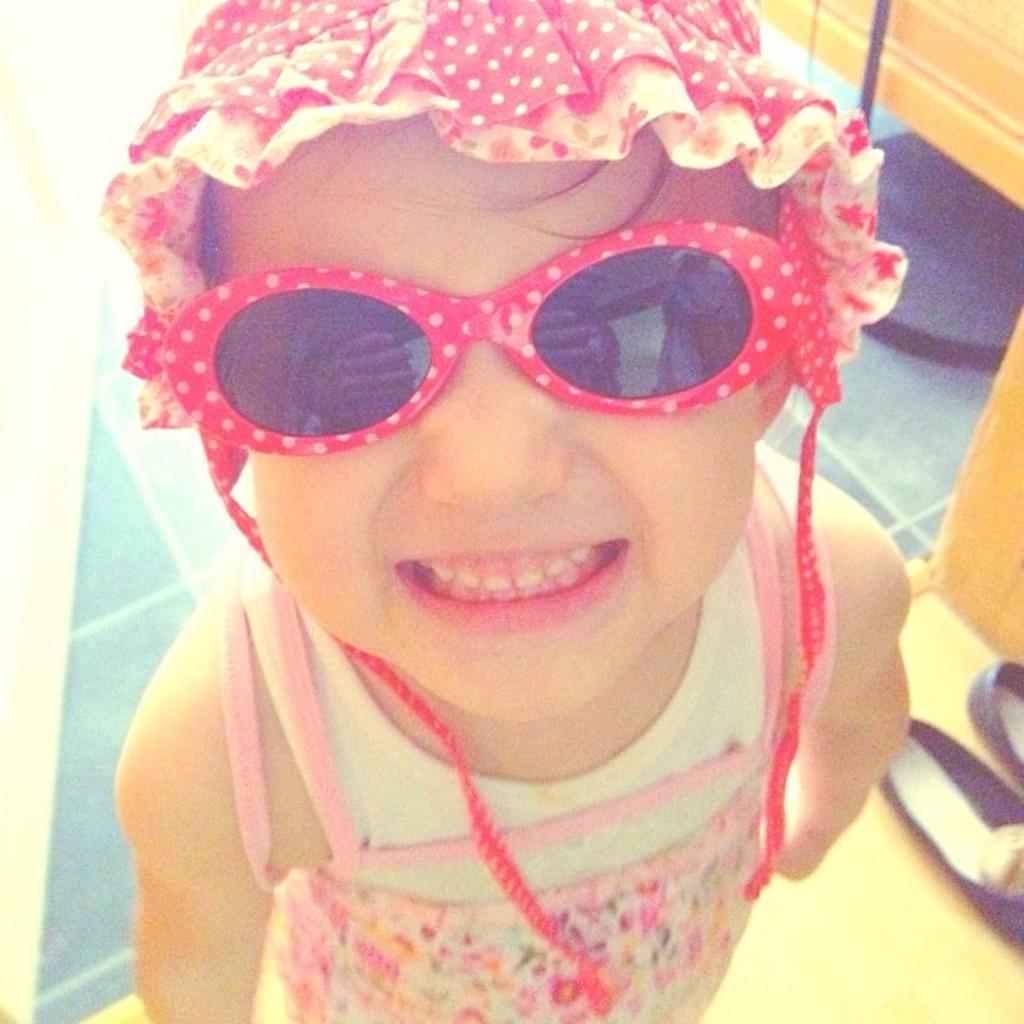Describe this image in one or two sentences. In this picture we can see a child, this child is wearing a cap and goggles, beside this child we can see sandals and in the background we can see a floor and some objects. 